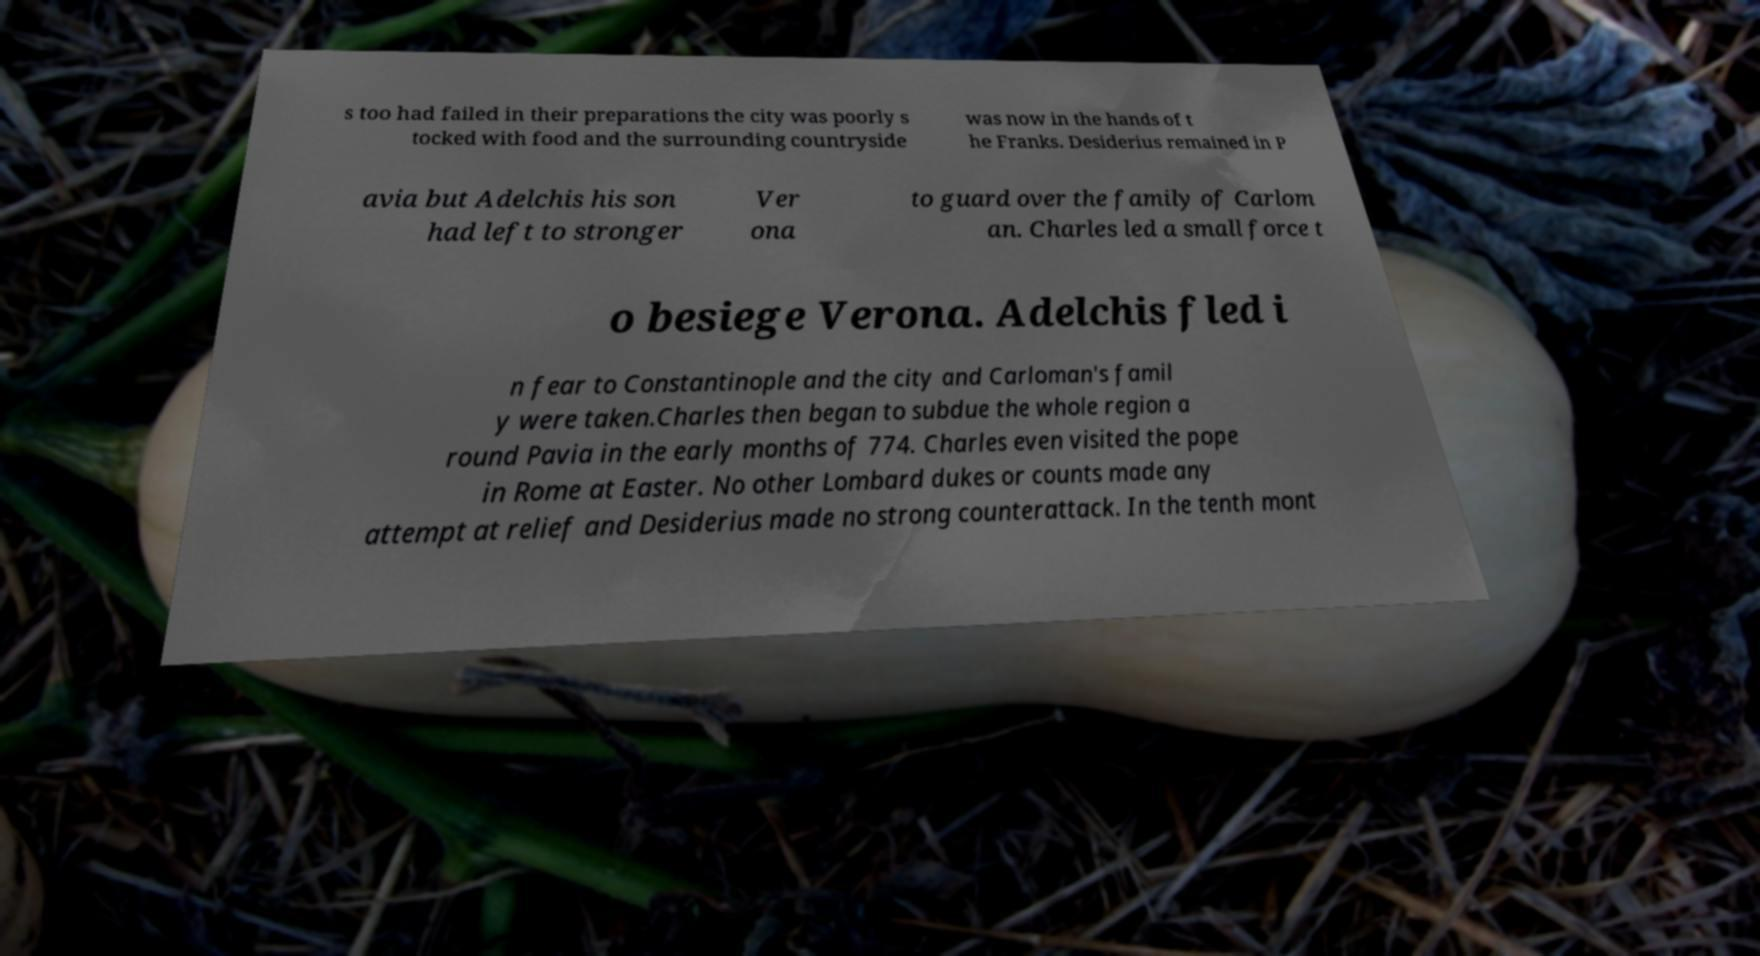For documentation purposes, I need the text within this image transcribed. Could you provide that? s too had failed in their preparations the city was poorly s tocked with food and the surrounding countryside was now in the hands of t he Franks. Desiderius remained in P avia but Adelchis his son had left to stronger Ver ona to guard over the family of Carlom an. Charles led a small force t o besiege Verona. Adelchis fled i n fear to Constantinople and the city and Carloman's famil y were taken.Charles then began to subdue the whole region a round Pavia in the early months of 774. Charles even visited the pope in Rome at Easter. No other Lombard dukes or counts made any attempt at relief and Desiderius made no strong counterattack. In the tenth mont 